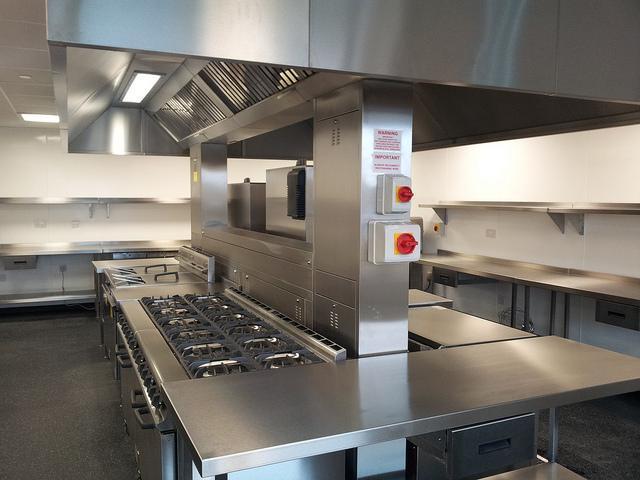How many orange cones are in the street?
Give a very brief answer. 0. 